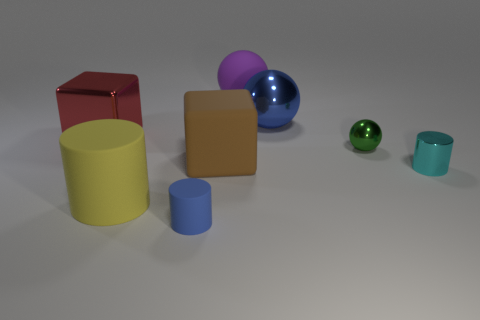Subtract all tiny blue cylinders. How many cylinders are left? 2 Add 1 big yellow matte objects. How many objects exist? 9 Subtract all yellow cylinders. How many cylinders are left? 2 Subtract 0 green blocks. How many objects are left? 8 Subtract all cylinders. How many objects are left? 5 Subtract 1 cylinders. How many cylinders are left? 2 Subtract all red cylinders. Subtract all gray cubes. How many cylinders are left? 3 Subtract all brown blocks. How many cyan cylinders are left? 1 Subtract all small blue matte cylinders. Subtract all blue matte cylinders. How many objects are left? 6 Add 1 cyan shiny objects. How many cyan shiny objects are left? 2 